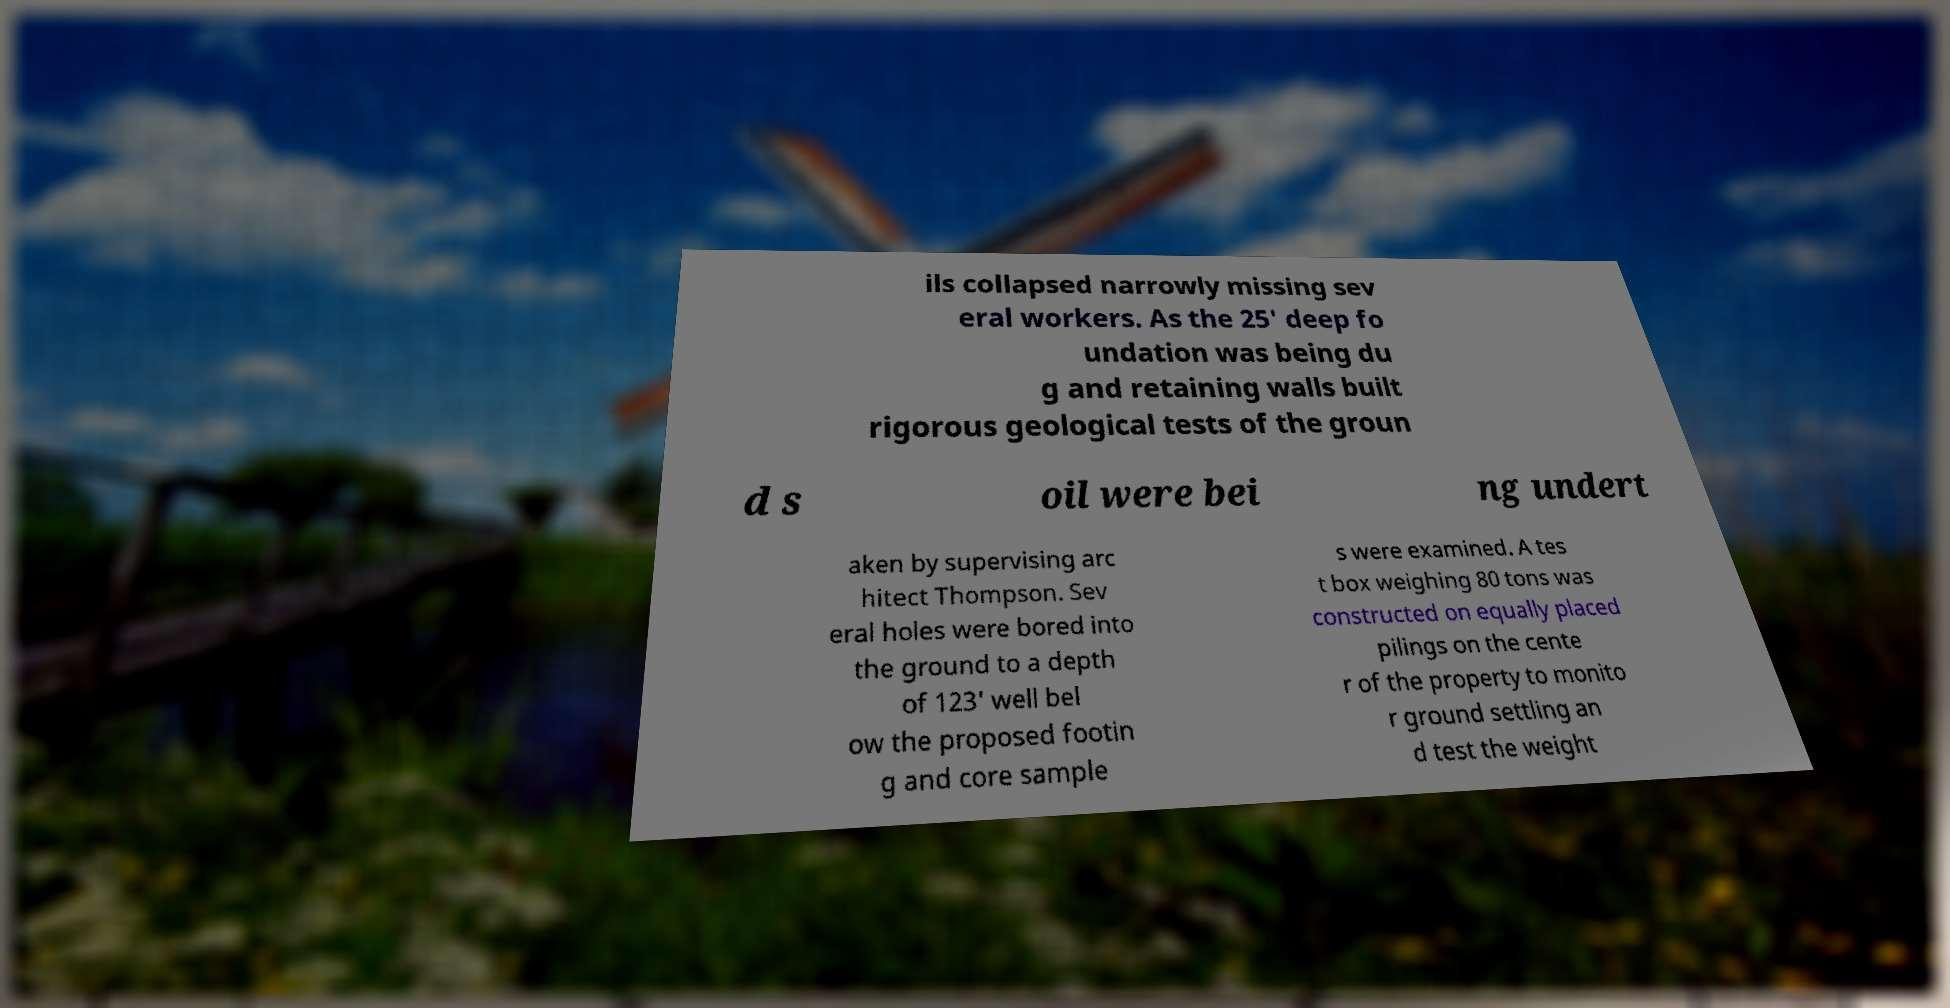Could you extract and type out the text from this image? ils collapsed narrowly missing sev eral workers. As the 25' deep fo undation was being du g and retaining walls built rigorous geological tests of the groun d s oil were bei ng undert aken by supervising arc hitect Thompson. Sev eral holes were bored into the ground to a depth of 123' well bel ow the proposed footin g and core sample s were examined. A tes t box weighing 80 tons was constructed on equally placed pilings on the cente r of the property to monito r ground settling an d test the weight 